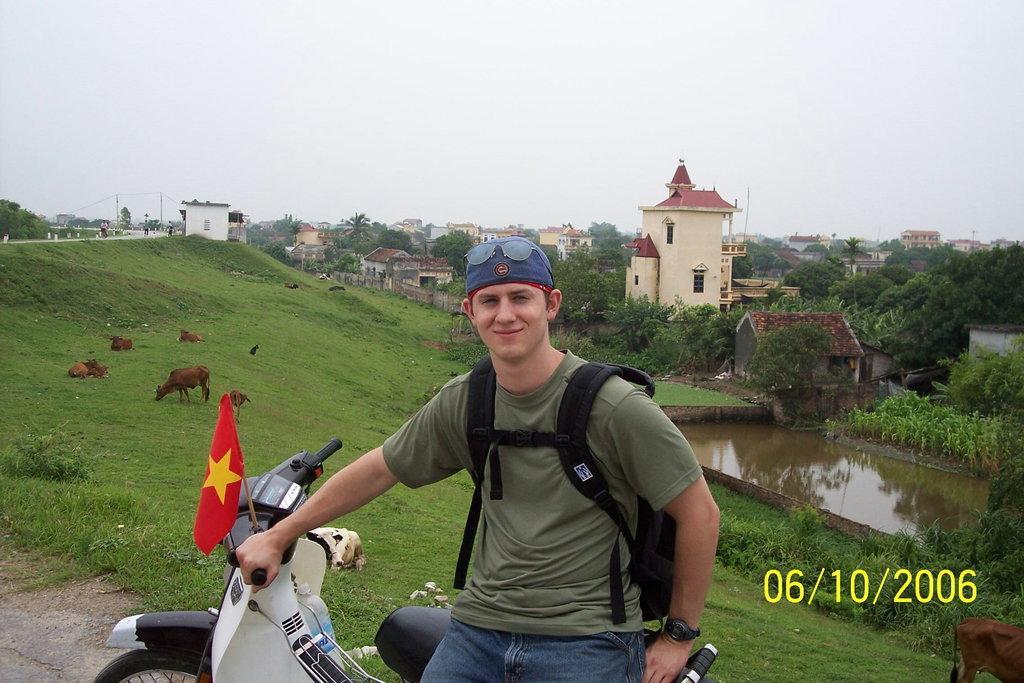Could you give a brief overview of what you see in this image? In this picture there is a person sitting on the vehicle and there is a flag on the vehicle. At the back there are buildings and trees and there are group of people on the road and there are animals. At the top there is sky. At the bottom there is water and there is grass and there is a road. 